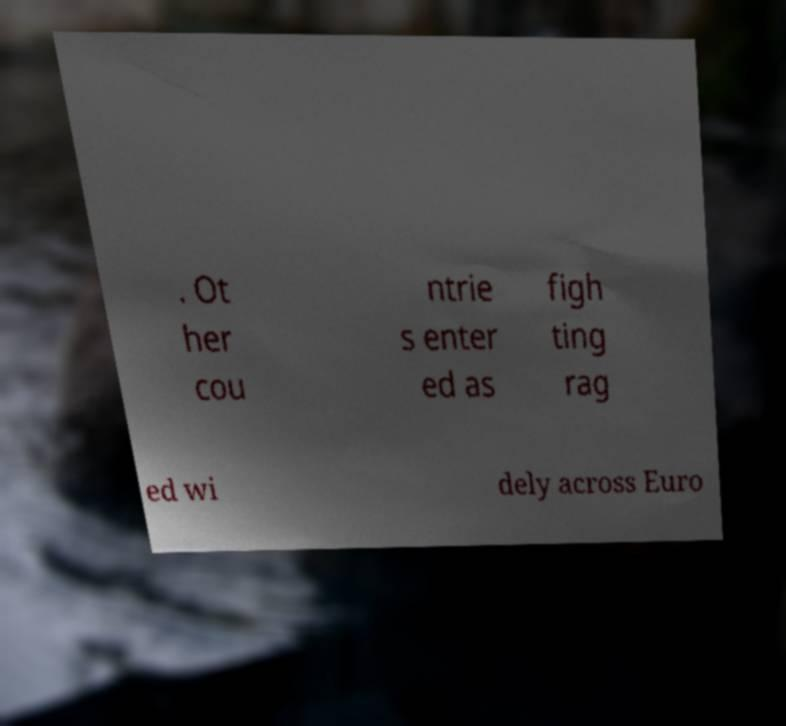Could you assist in decoding the text presented in this image and type it out clearly? . Ot her cou ntrie s enter ed as figh ting rag ed wi dely across Euro 